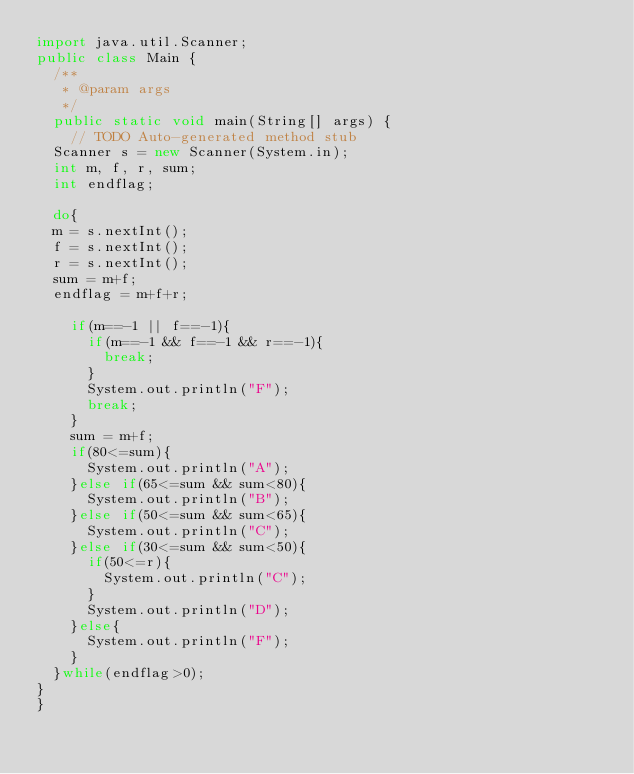<code> <loc_0><loc_0><loc_500><loc_500><_Java_>import java.util.Scanner;
public class Main {
	/**
	 * @param args
	 */
	public static void main(String[] args) {
		// TODO Auto-generated method stub
	Scanner s = new Scanner(System.in);
	int m, f, r, sum;
	int endflag;
	
	do{
	m = s.nextInt();
	f = s.nextInt();
	r = s.nextInt();
	sum = m+f;
	endflag = m+f+r;

		if(m==-1 || f==-1){
			if(m==-1 && f==-1 && r==-1){
				break;
			}
			System.out.println("F");
			break;
		}
		sum = m+f;
		if(80<=sum){
			System.out.println("A");
		}else if(65<=sum && sum<80){
			System.out.println("B");
		}else if(50<=sum && sum<65){
			System.out.println("C");
		}else if(30<=sum && sum<50){
			if(50<=r){
				System.out.println("C");
			}
			System.out.println("D");
		}else{
			System.out.println("F");
		}
	}while(endflag>0);
}
}</code> 